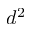<formula> <loc_0><loc_0><loc_500><loc_500>d ^ { 2 }</formula> 